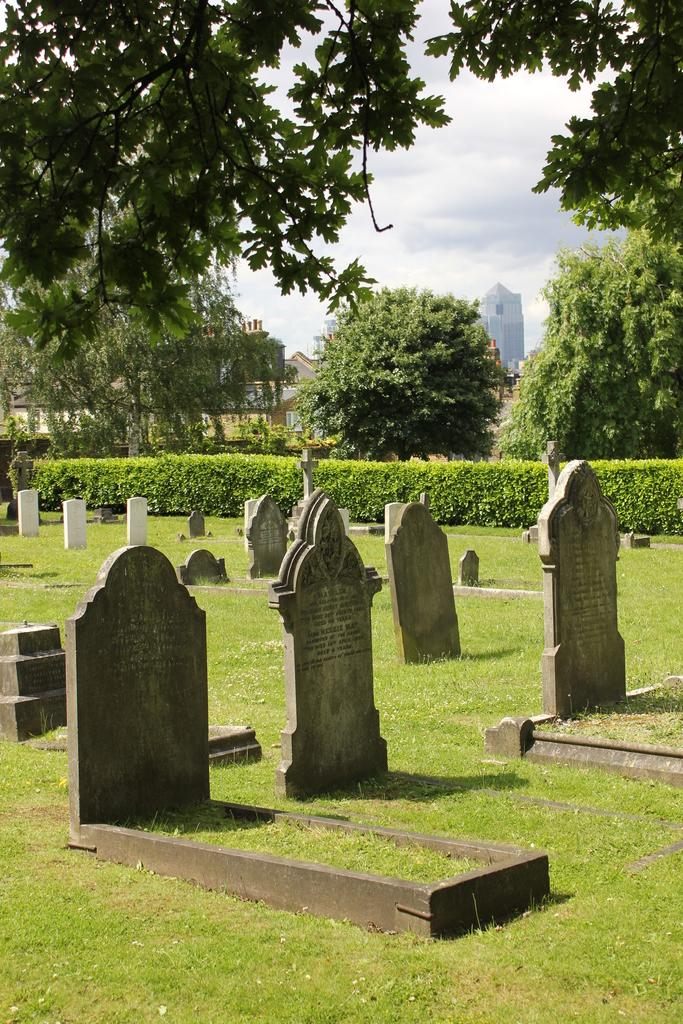What is the main subject of the image? The main subject of the image is a graveyard. What can be seen in the background of the image? There are trees in the background of the image. What is the opinion of the bee about the snake in the image? There is no bee or snake present in the image, so it is not possible to determine their opinions. 